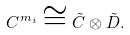<formula> <loc_0><loc_0><loc_500><loc_500>C ^ { m _ { i } } \cong \tilde { C } \otimes \tilde { D } .</formula> 